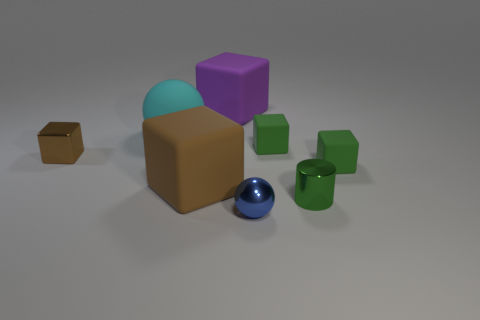Subtract all cyan cubes. Subtract all gray cylinders. How many cubes are left? 5 Add 1 big blocks. How many objects exist? 9 Subtract all spheres. How many objects are left? 6 Add 8 tiny cylinders. How many tiny cylinders are left? 9 Add 8 purple rubber balls. How many purple rubber balls exist? 8 Subtract 0 blue blocks. How many objects are left? 8 Subtract all small cubes. Subtract all tiny metal objects. How many objects are left? 2 